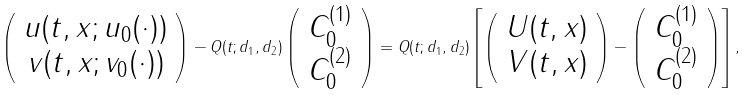Convert formula to latex. <formula><loc_0><loc_0><loc_500><loc_500>\left ( \begin{array} { c c } u ( t , x ; u _ { 0 } ( \cdot ) ) \\ v ( t , x ; v _ { 0 } ( \cdot ) ) \end{array} \right ) - Q ( t ; d _ { 1 } , d _ { 2 } ) \left ( \begin{array} { c c } C _ { 0 } ^ { ( 1 ) } \\ C _ { 0 } ^ { ( 2 ) } \end{array} \right ) = Q ( t ; d _ { 1 } , d _ { 2 } ) \left [ \left ( \begin{array} { c c c c } U ( t , x ) \\ V ( t , x ) \end{array} \right ) - \left ( \begin{array} { c c c c } C _ { 0 } ^ { ( 1 ) } \\ C _ { 0 } ^ { ( 2 ) } \end{array} \right ) \right ] ,</formula> 